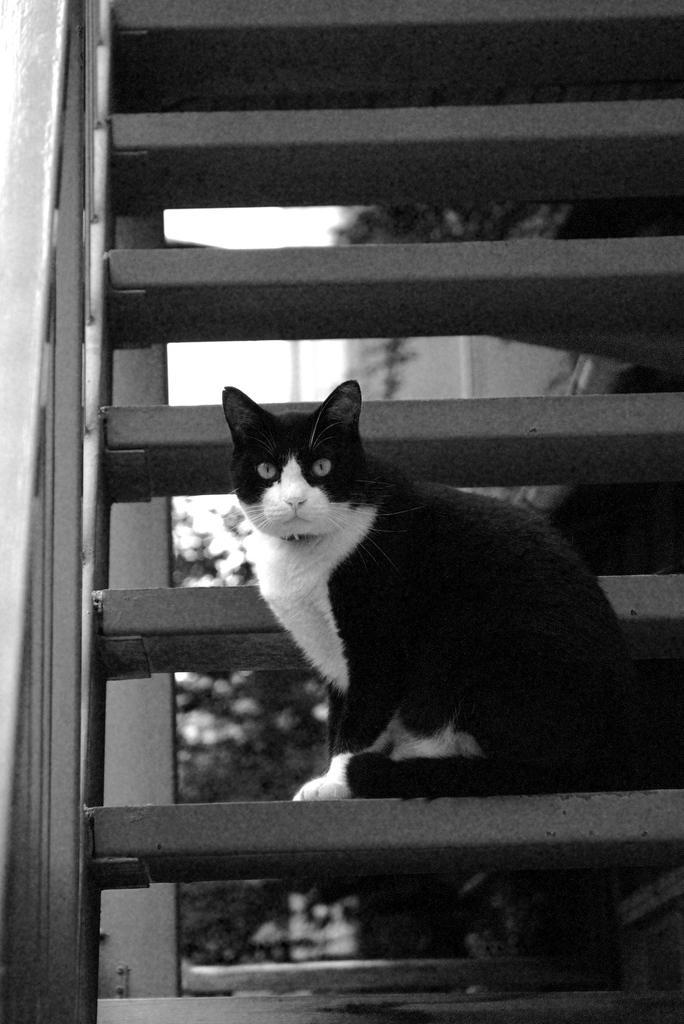How would you summarize this image in a sentence or two? This is a black and white image. In this image we can see a cat on the staircase. On the backside we can see some plants. 